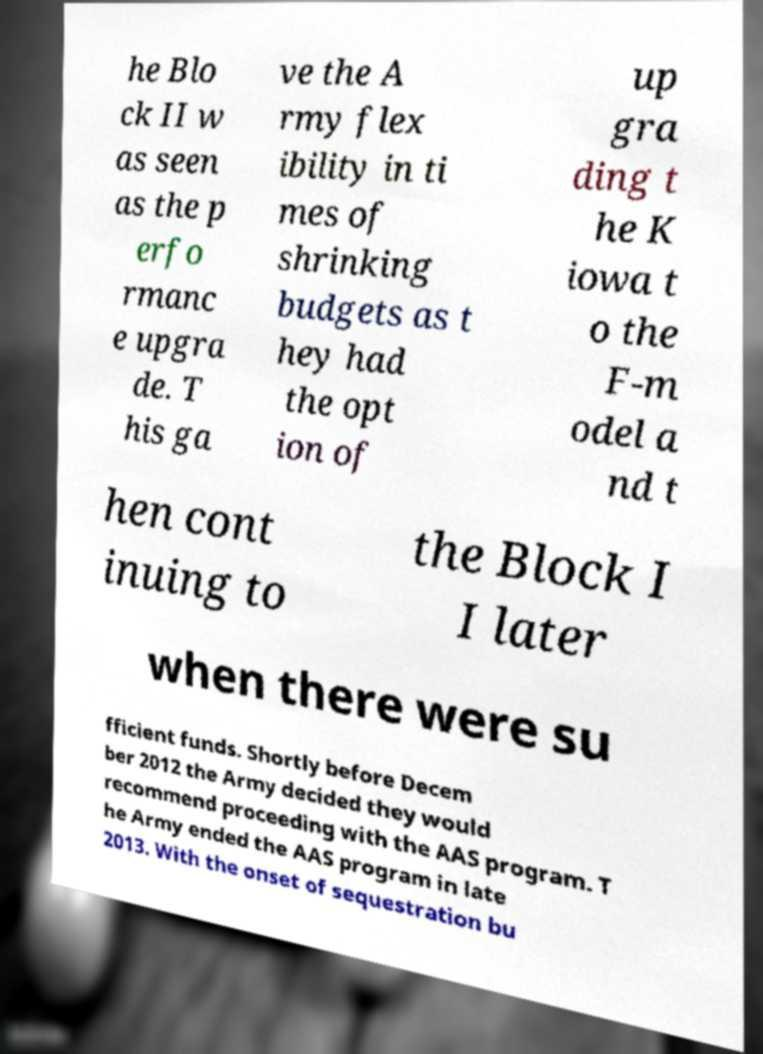Can you accurately transcribe the text from the provided image for me? he Blo ck II w as seen as the p erfo rmanc e upgra de. T his ga ve the A rmy flex ibility in ti mes of shrinking budgets as t hey had the opt ion of up gra ding t he K iowa t o the F-m odel a nd t hen cont inuing to the Block I I later when there were su fficient funds. Shortly before Decem ber 2012 the Army decided they would recommend proceeding with the AAS program. T he Army ended the AAS program in late 2013. With the onset of sequestration bu 